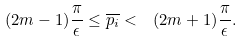<formula> <loc_0><loc_0><loc_500><loc_500>( 2 m - 1 ) \frac { \pi } { \epsilon } \leq \overline { p _ { i } } < \ ( 2 m + 1 ) \frac { \pi } { \epsilon } .</formula> 